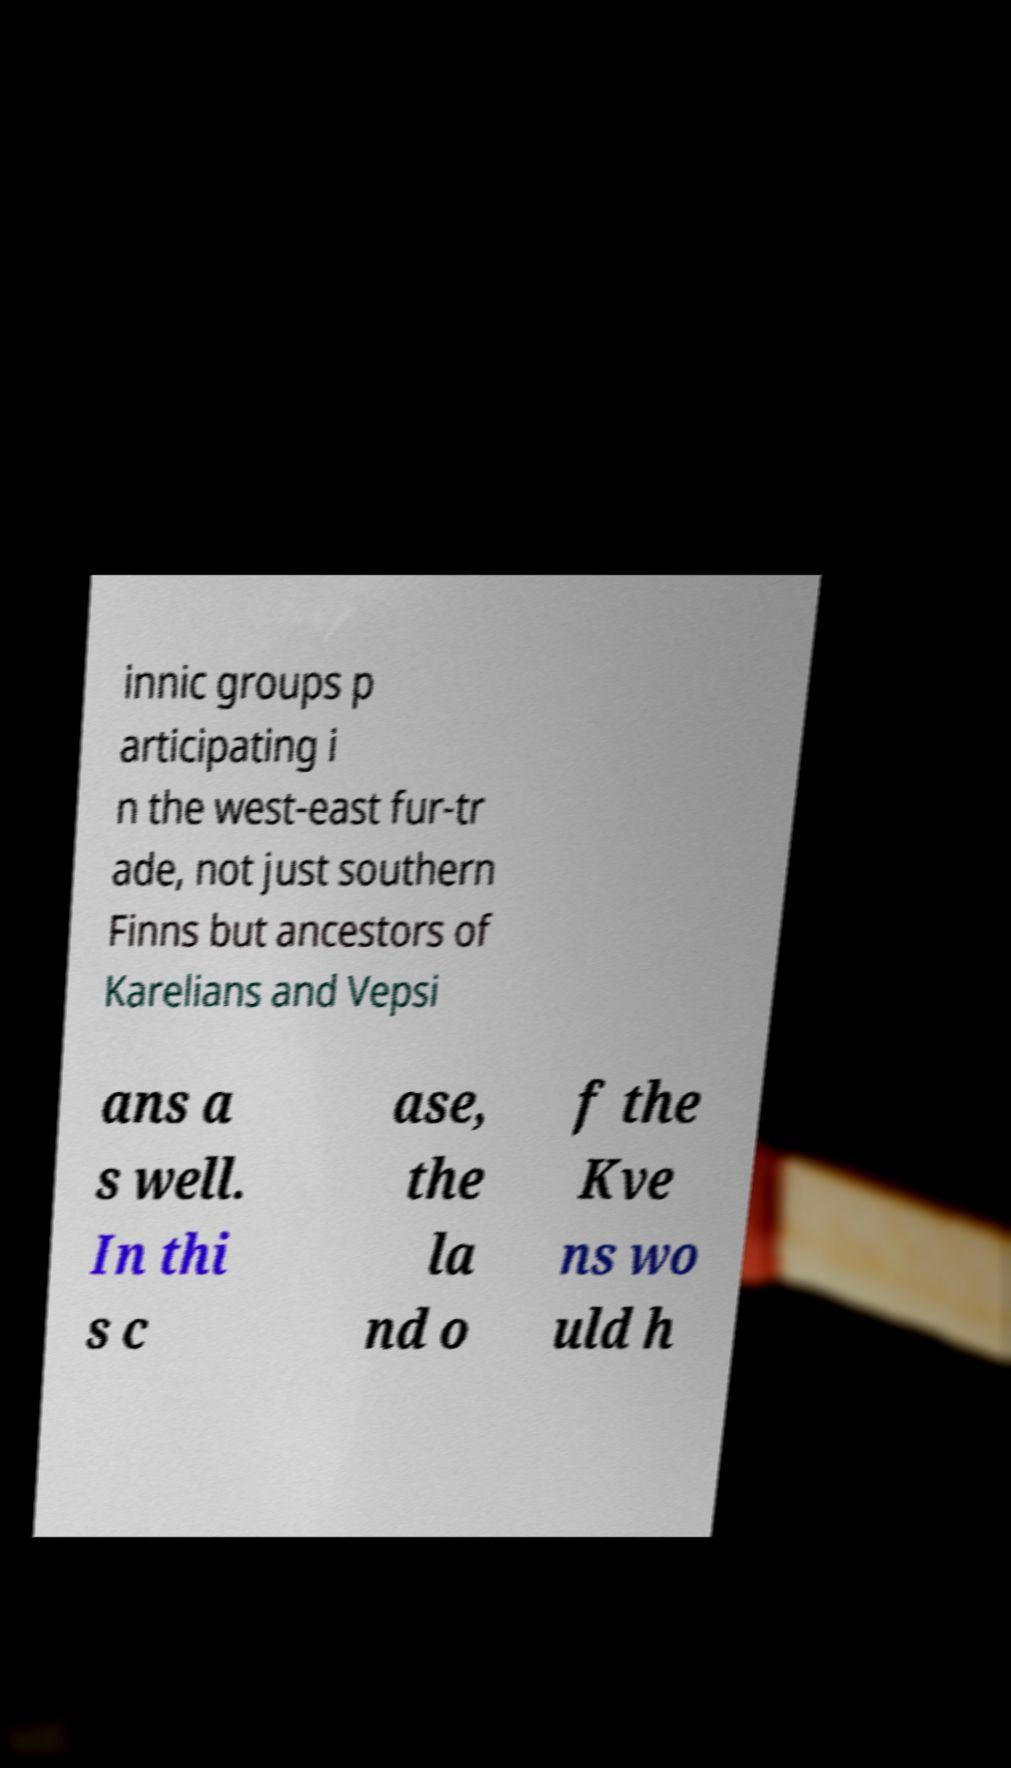Could you extract and type out the text from this image? innic groups p articipating i n the west-east fur-tr ade, not just southern Finns but ancestors of Karelians and Vepsi ans a s well. In thi s c ase, the la nd o f the Kve ns wo uld h 